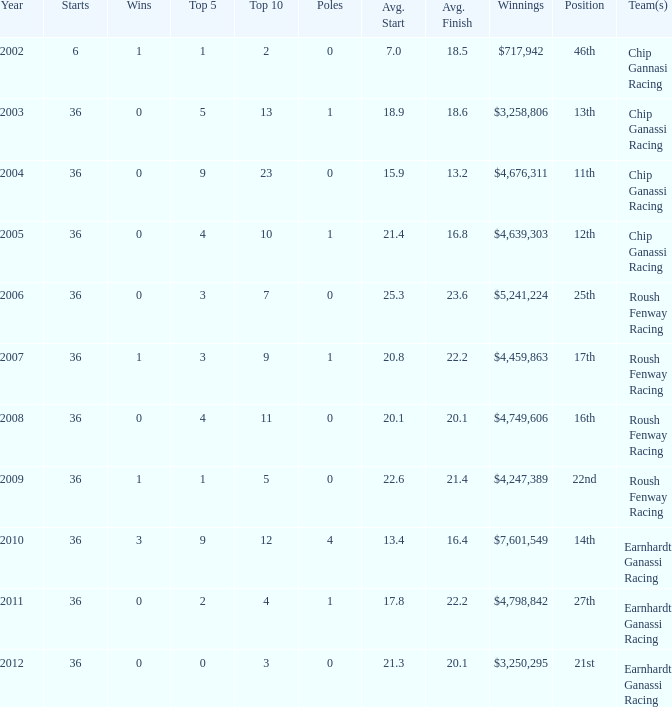What are the starts when the placement is 16th? 36.0. 